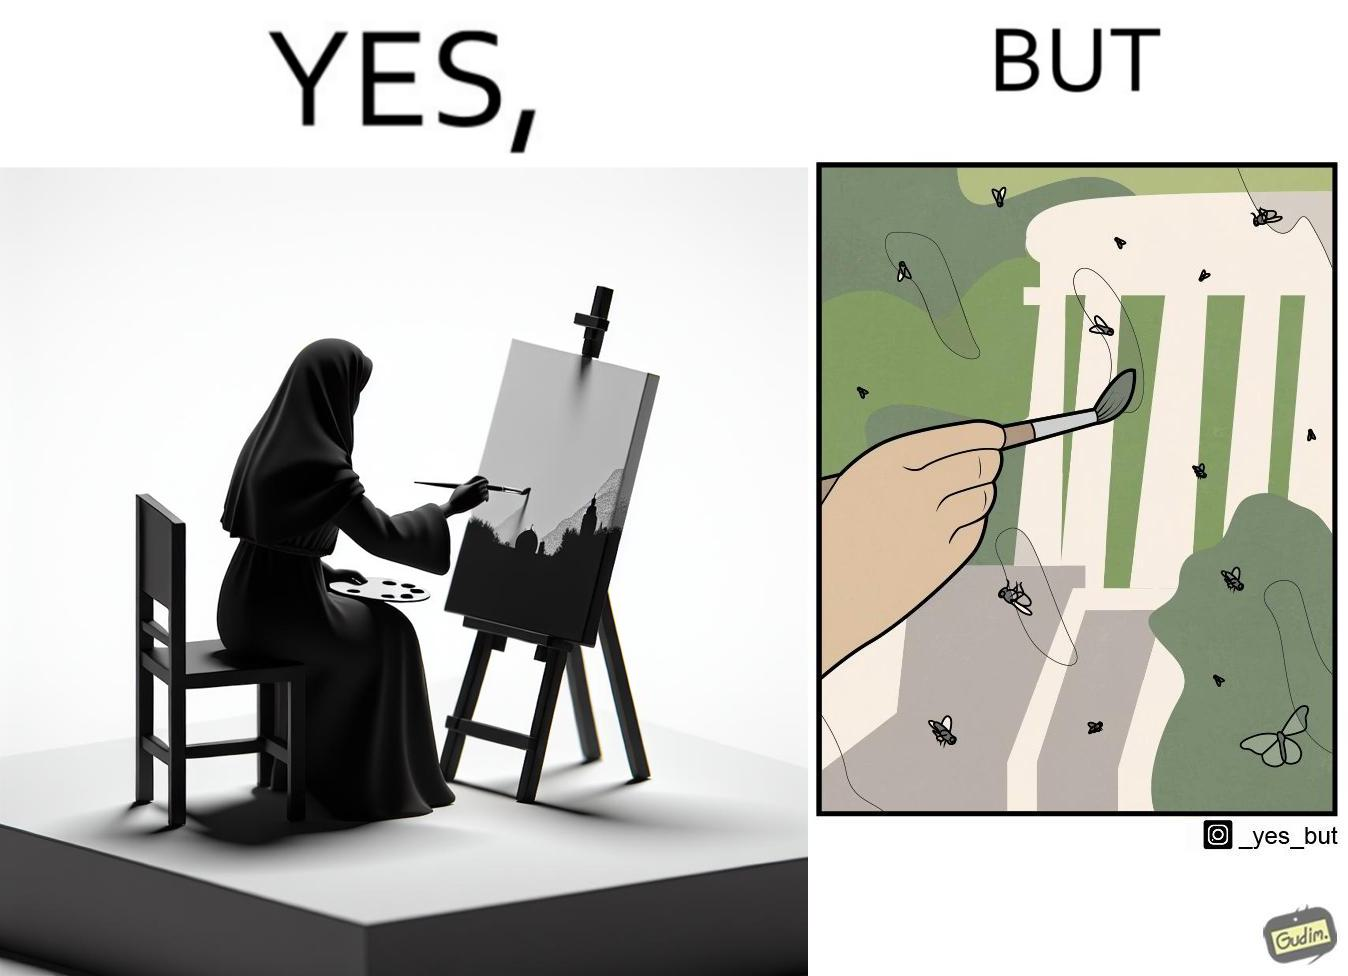Describe what you see in the left and right parts of this image. In the left part of the image: It is a woman painting a natural scenery In the right part of the image: A number of flies stuck on a painting 